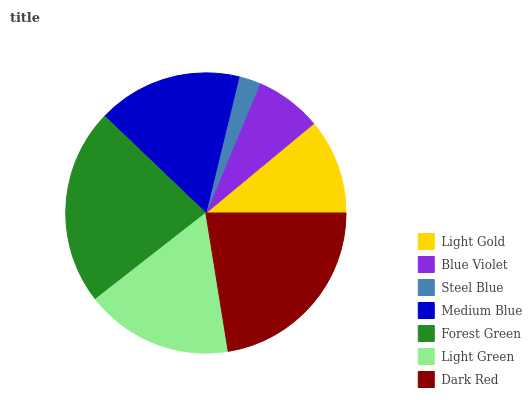Is Steel Blue the minimum?
Answer yes or no. Yes. Is Forest Green the maximum?
Answer yes or no. Yes. Is Blue Violet the minimum?
Answer yes or no. No. Is Blue Violet the maximum?
Answer yes or no. No. Is Light Gold greater than Blue Violet?
Answer yes or no. Yes. Is Blue Violet less than Light Gold?
Answer yes or no. Yes. Is Blue Violet greater than Light Gold?
Answer yes or no. No. Is Light Gold less than Blue Violet?
Answer yes or no. No. Is Medium Blue the high median?
Answer yes or no. Yes. Is Medium Blue the low median?
Answer yes or no. Yes. Is Light Green the high median?
Answer yes or no. No. Is Blue Violet the low median?
Answer yes or no. No. 